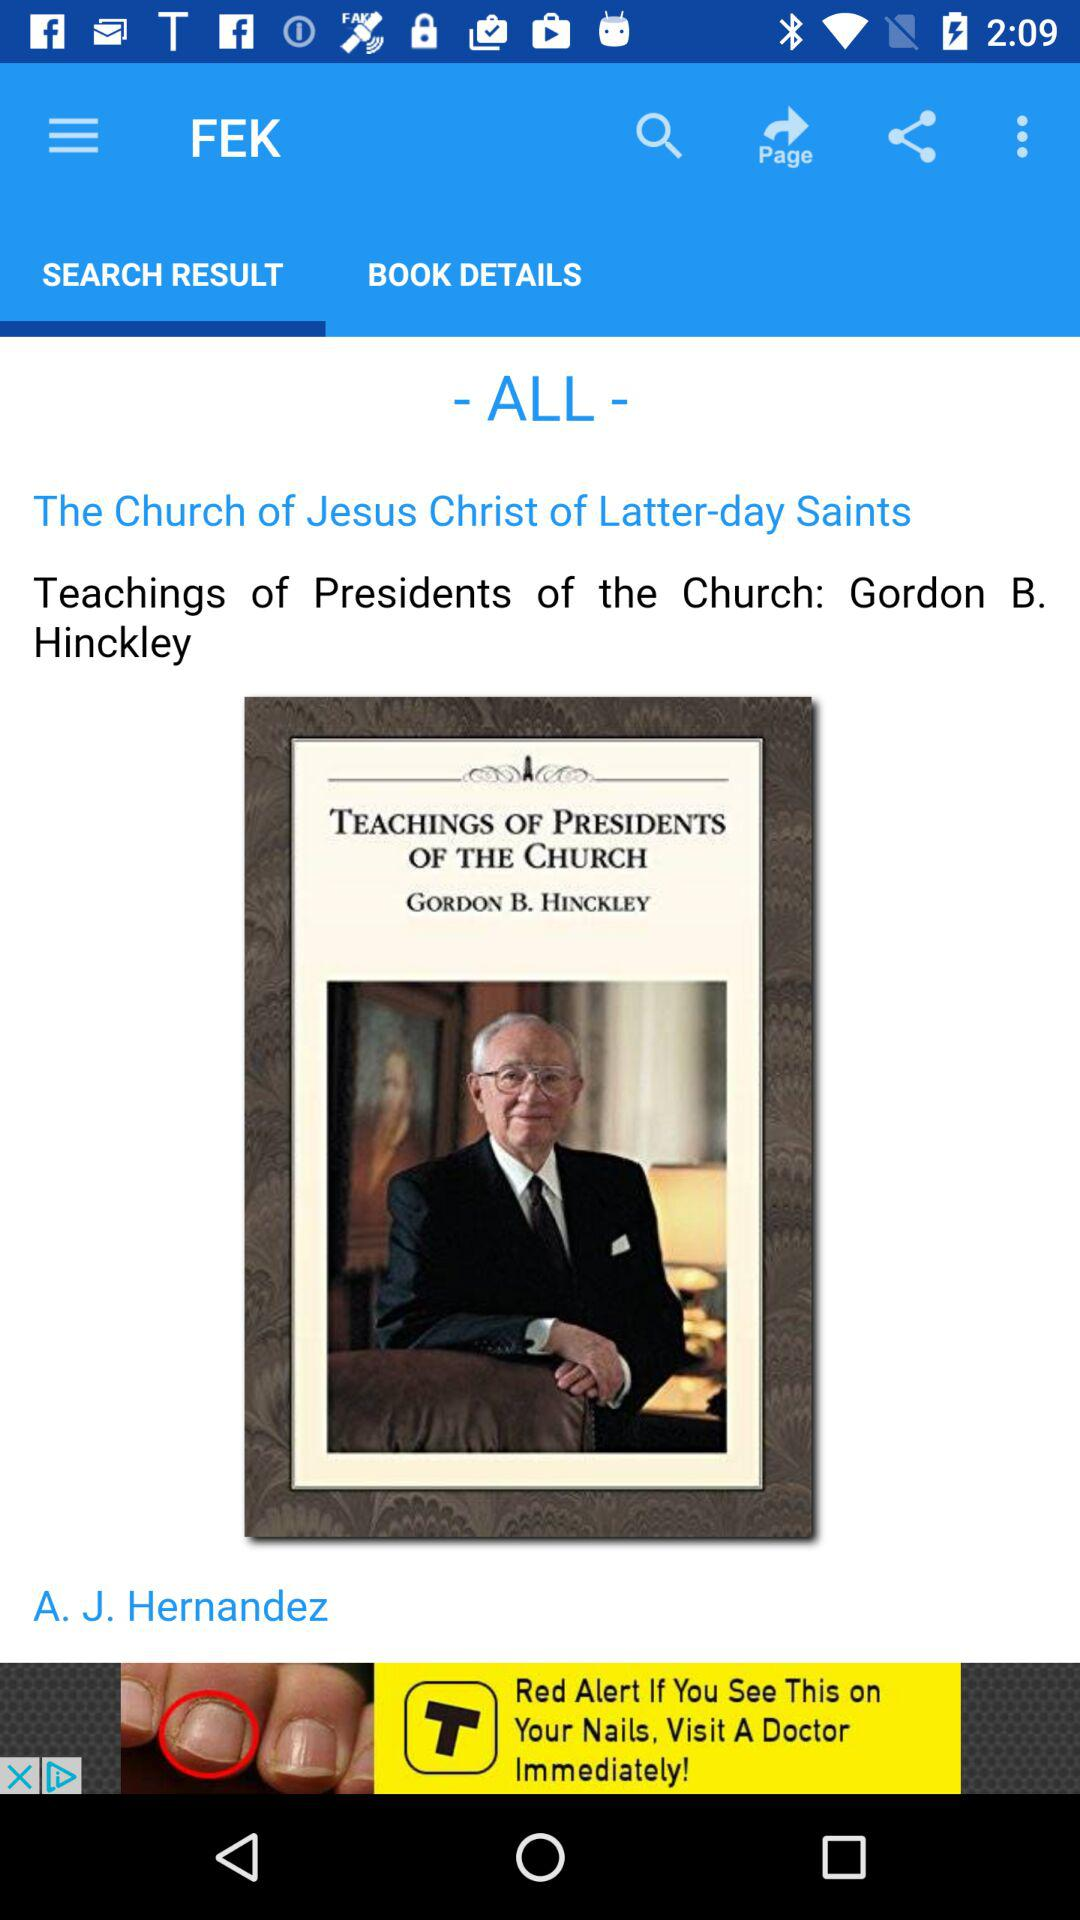What are the book details?
When the provided information is insufficient, respond with <no answer>. <no answer> 